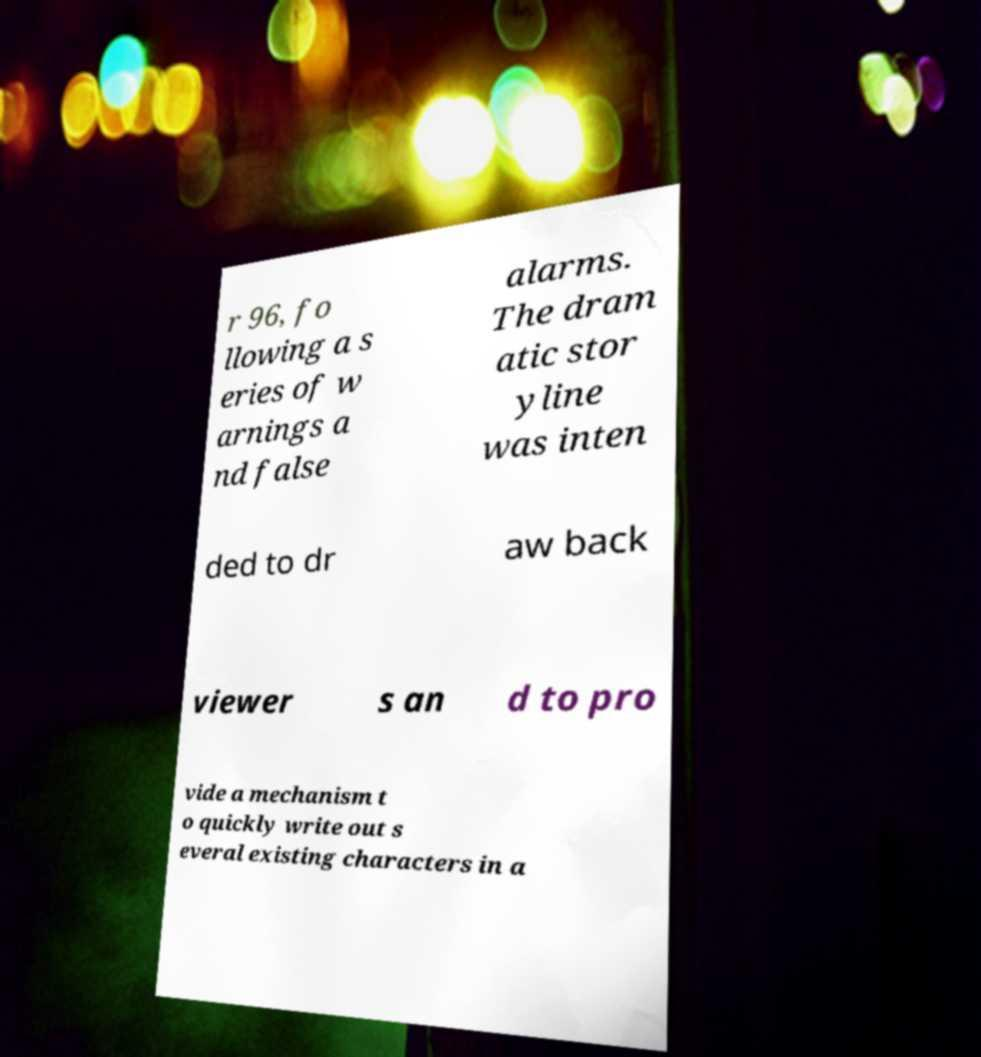I need the written content from this picture converted into text. Can you do that? r 96, fo llowing a s eries of w arnings a nd false alarms. The dram atic stor yline was inten ded to dr aw back viewer s an d to pro vide a mechanism t o quickly write out s everal existing characters in a 